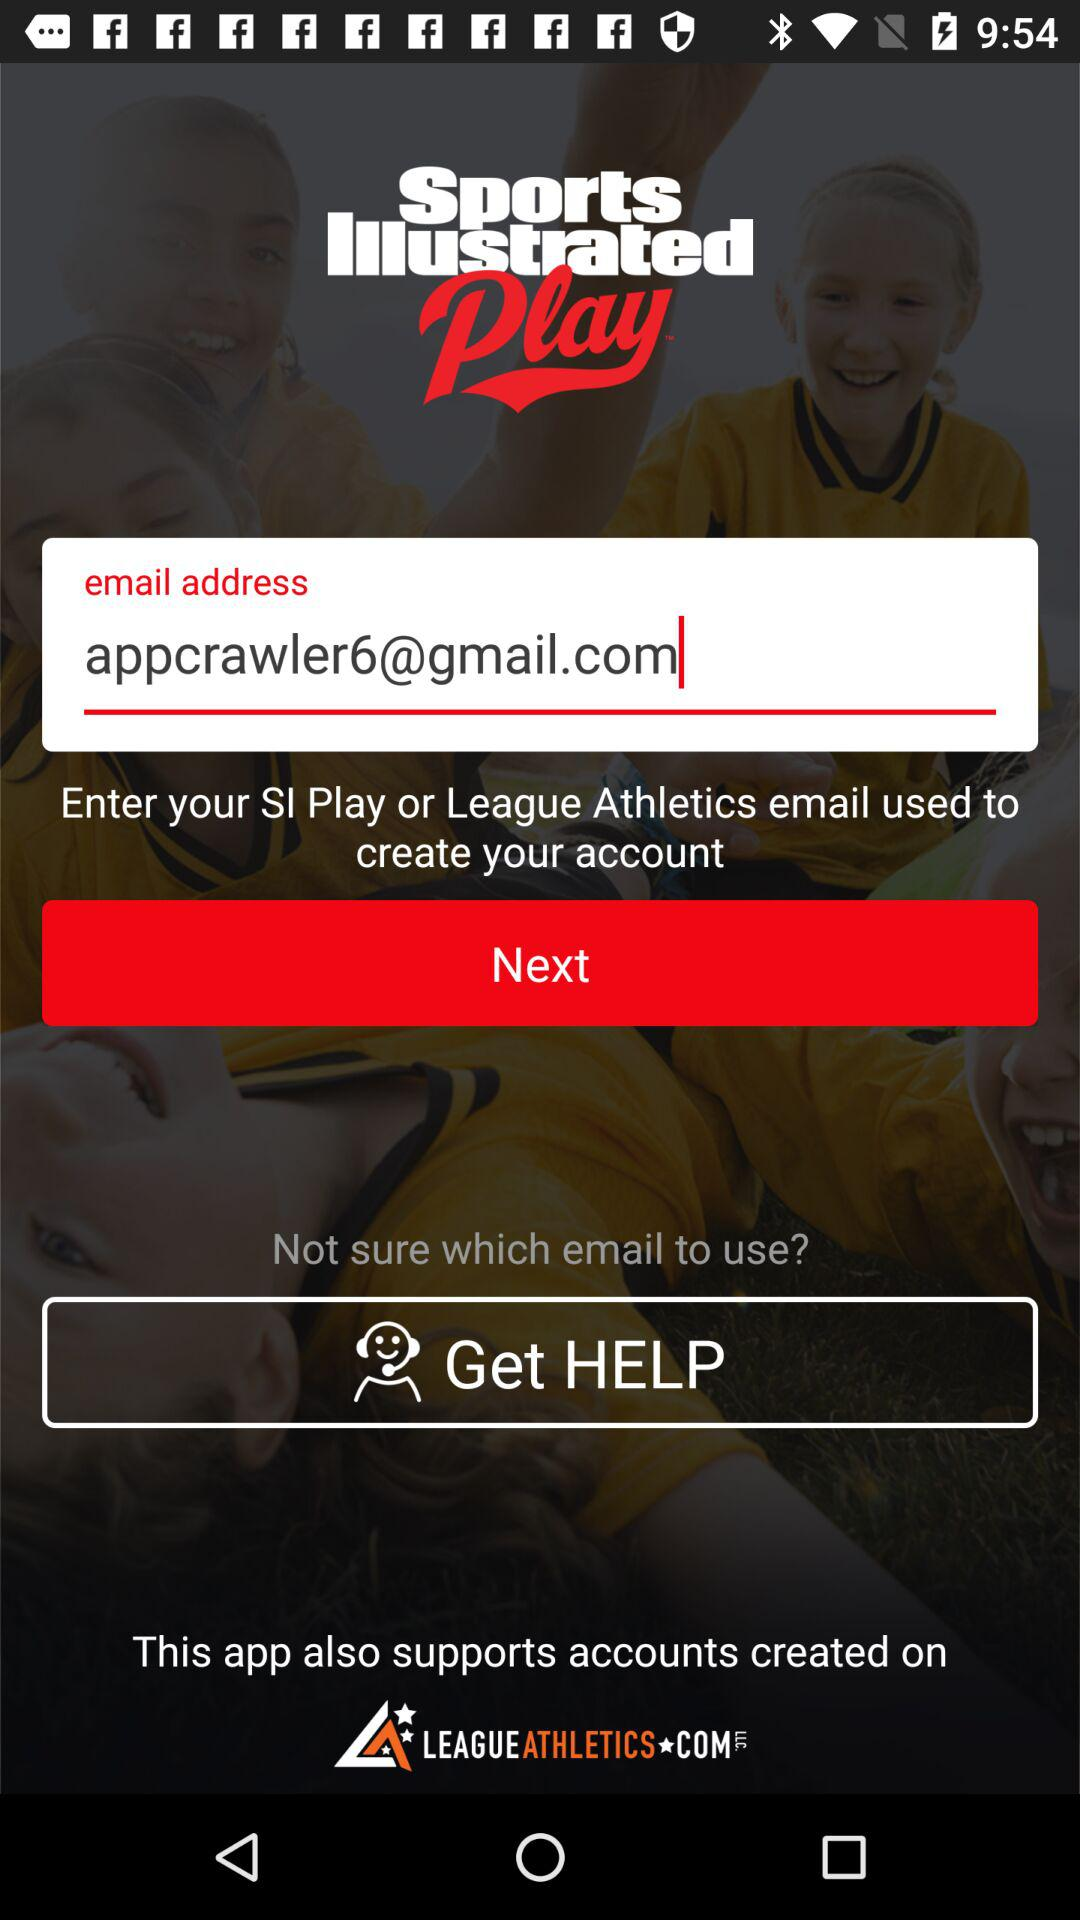What is the email address entered to create an account? The entered email address is appcrawler6@gmail.com. 